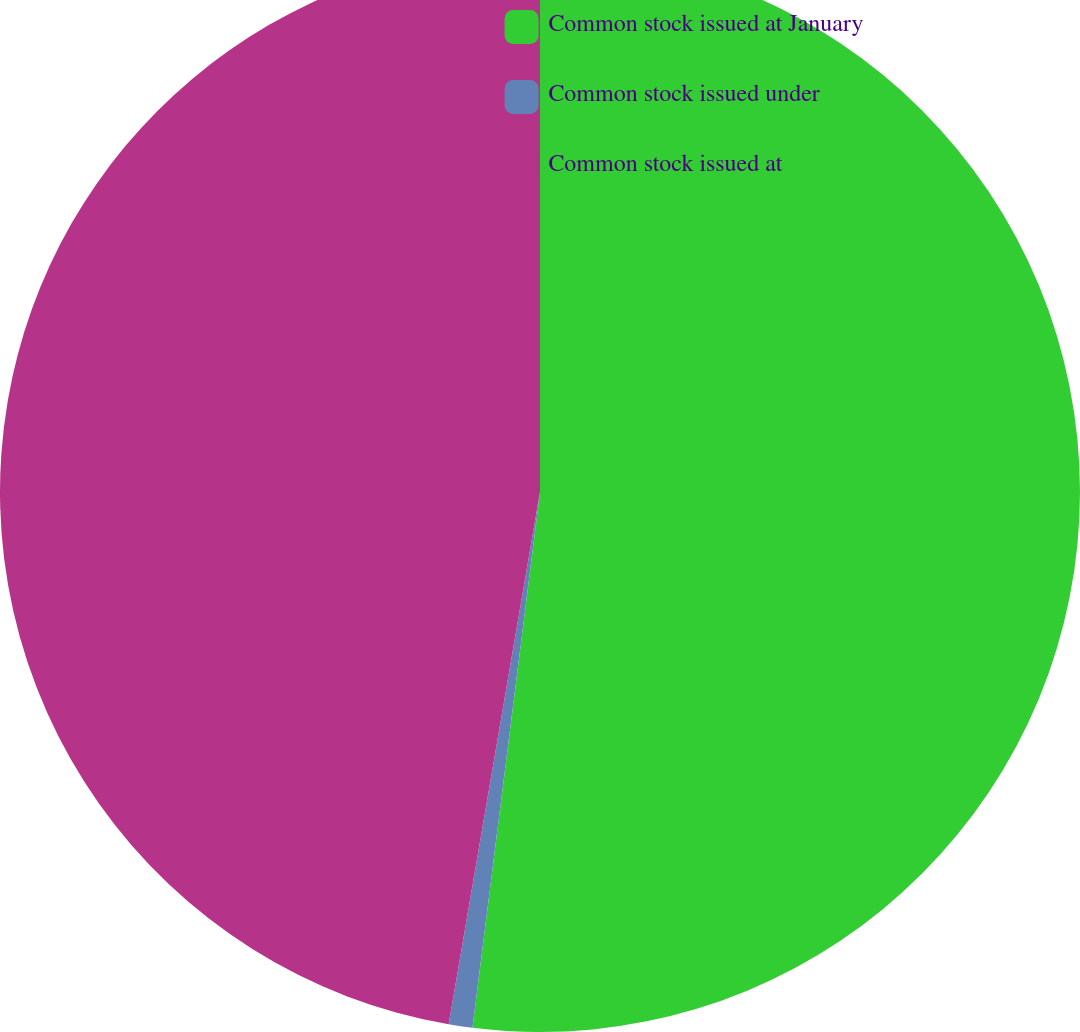Convert chart to OTSL. <chart><loc_0><loc_0><loc_500><loc_500><pie_chart><fcel>Common stock issued at January<fcel>Common stock issued under<fcel>Common stock issued at<nl><fcel>52.0%<fcel>0.71%<fcel>47.3%<nl></chart> 